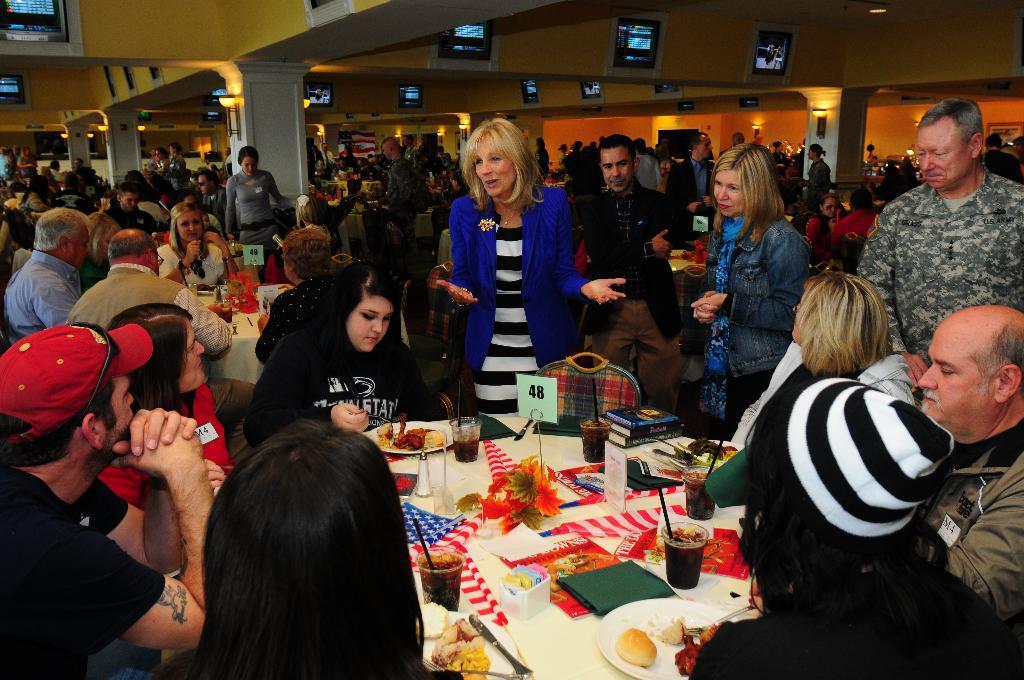How would you summarize this image in a sentence or two? In this picture we can see some persons sitting on the chairs. This is the table. On the table there are glasses, plates, and some food. Here we can see persons standing on the floor. This is the pillar and these are the screens. Here we can see some lights. 